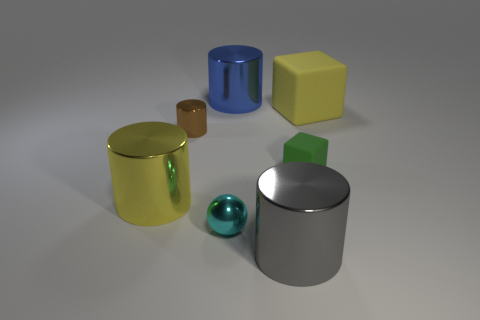Subtract all gray metallic cylinders. How many cylinders are left? 3 Add 3 green metal cylinders. How many objects exist? 10 Subtract all gray cylinders. How many cylinders are left? 3 Subtract 2 cylinders. How many cylinders are left? 2 Subtract all cubes. How many objects are left? 5 Subtract 0 green spheres. How many objects are left? 7 Subtract all brown cylinders. Subtract all brown blocks. How many cylinders are left? 3 Subtract all big yellow shiny balls. Subtract all big yellow matte things. How many objects are left? 6 Add 6 big metal objects. How many big metal objects are left? 9 Add 1 shiny balls. How many shiny balls exist? 2 